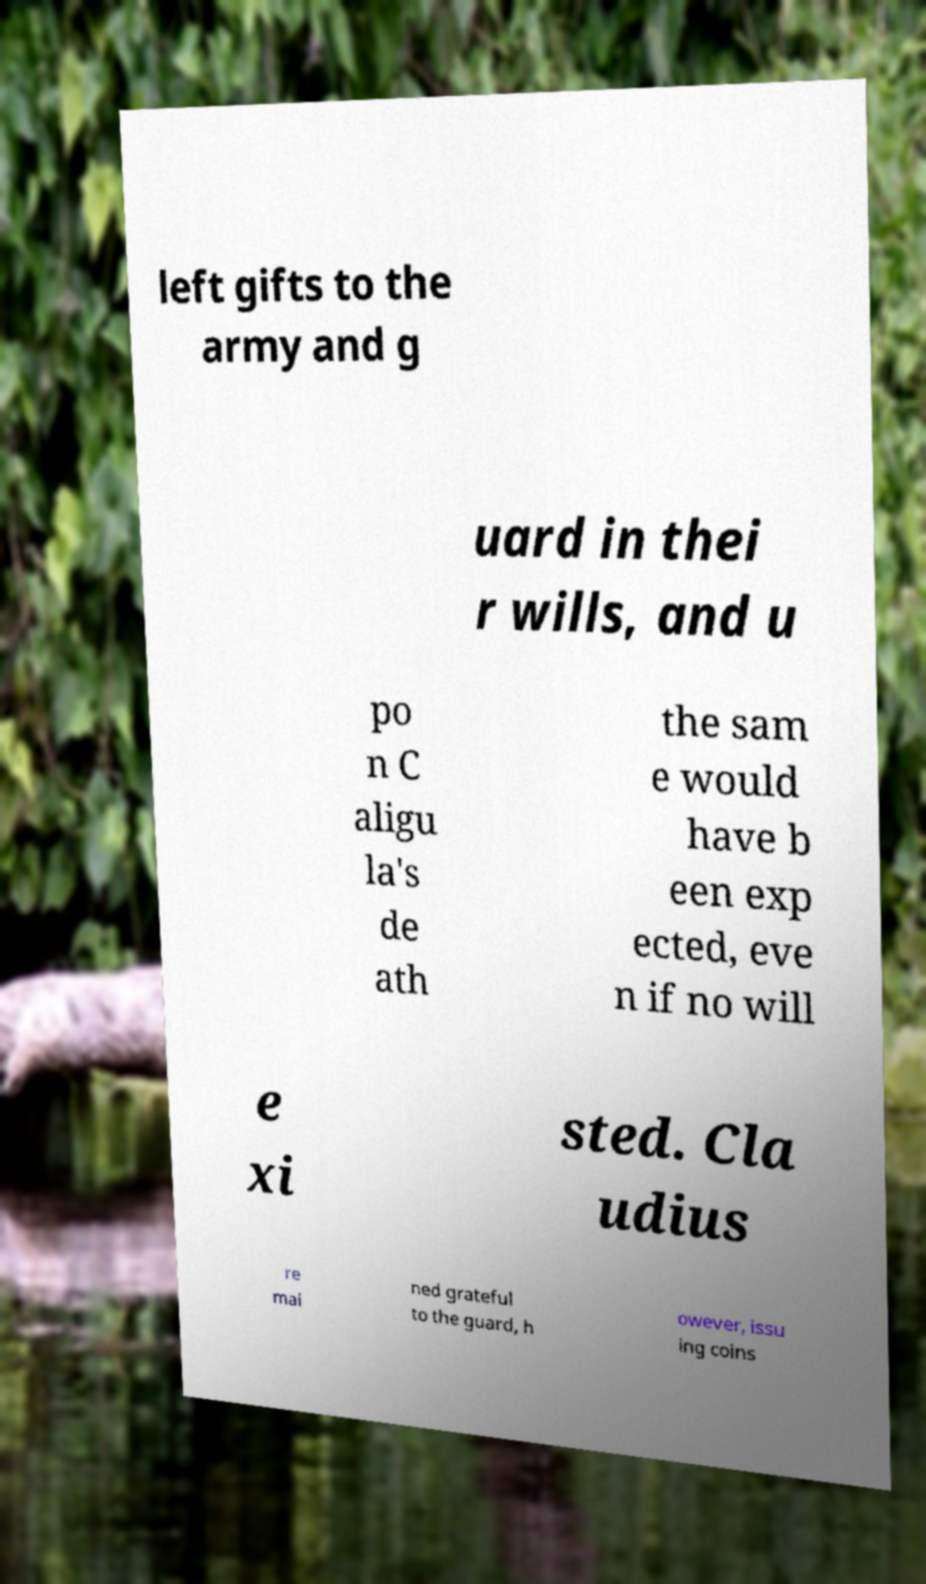Please identify and transcribe the text found in this image. left gifts to the army and g uard in thei r wills, and u po n C aligu la's de ath the sam e would have b een exp ected, eve n if no will e xi sted. Cla udius re mai ned grateful to the guard, h owever, issu ing coins 